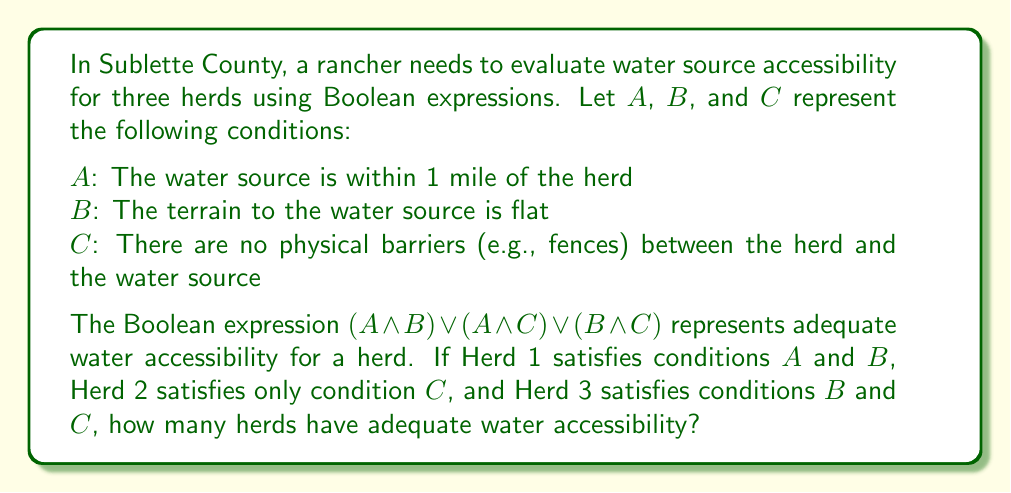Provide a solution to this math problem. Let's evaluate the Boolean expression $(A \wedge B) \vee (A \wedge C) \vee (B \wedge C)$ for each herd:

1. Herd 1: $A = 1$, $B = 1$, $C = 0$
   $(1 \wedge 1) \vee (1 \wedge 0) \vee (1 \wedge 0) = 1 \vee 0 \vee 0 = 1$
   Herd 1 has adequate water accessibility.

2. Herd 2: $A = 0$, $B = 0$, $C = 1$
   $(0 \wedge 0) \vee (0 \wedge 1) \vee (0 \wedge 1) = 0 \vee 0 \vee 0 = 0$
   Herd 2 does not have adequate water accessibility.

3. Herd 3: $A = 0$, $B = 1$, $C = 1$
   $(0 \wedge 1) \vee (0 \wedge 1) \vee (1 \wedge 1) = 0 \vee 0 \vee 1 = 1$
   Herd 3 has adequate water accessibility.

Counting the number of herds with adequate water accessibility:
Herd 1: Yes
Herd 2: No
Herd 3: Yes

Total: 2 herds have adequate water accessibility.
Answer: 2 